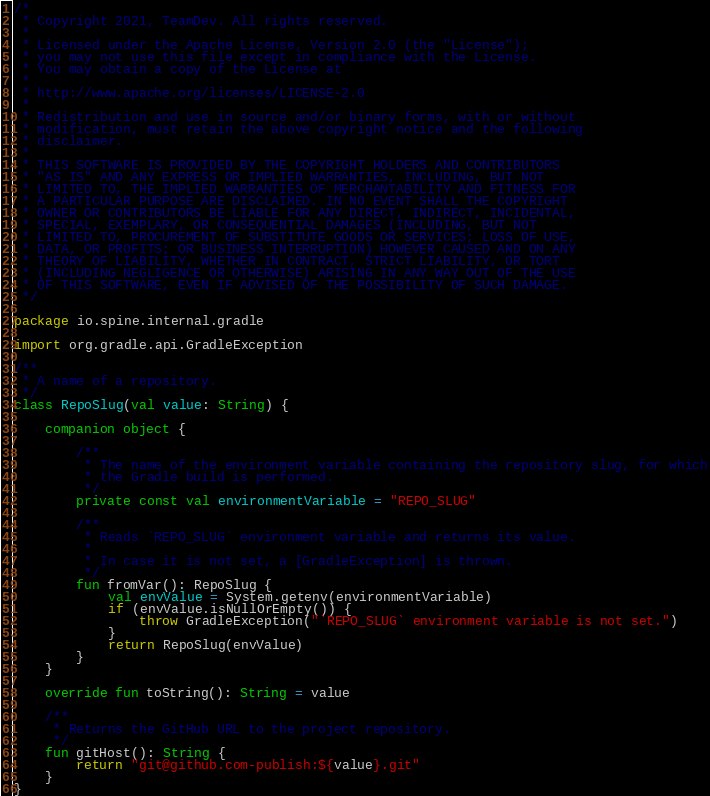<code> <loc_0><loc_0><loc_500><loc_500><_Kotlin_>/*
 * Copyright 2021, TeamDev. All rights reserved.
 *
 * Licensed under the Apache License, Version 2.0 (the "License");
 * you may not use this file except in compliance with the License.
 * You may obtain a copy of the License at
 *
 * http://www.apache.org/licenses/LICENSE-2.0
 *
 * Redistribution and use in source and/or binary forms, with or without
 * modification, must retain the above copyright notice and the following
 * disclaimer.
 *
 * THIS SOFTWARE IS PROVIDED BY THE COPYRIGHT HOLDERS AND CONTRIBUTORS
 * "AS IS" AND ANY EXPRESS OR IMPLIED WARRANTIES, INCLUDING, BUT NOT
 * LIMITED TO, THE IMPLIED WARRANTIES OF MERCHANTABILITY AND FITNESS FOR
 * A PARTICULAR PURPOSE ARE DISCLAIMED. IN NO EVENT SHALL THE COPYRIGHT
 * OWNER OR CONTRIBUTORS BE LIABLE FOR ANY DIRECT, INDIRECT, INCIDENTAL,
 * SPECIAL, EXEMPLARY, OR CONSEQUENTIAL DAMAGES (INCLUDING, BUT NOT
 * LIMITED TO, PROCUREMENT OF SUBSTITUTE GOODS OR SERVICES; LOSS OF USE,
 * DATA, OR PROFITS; OR BUSINESS INTERRUPTION) HOWEVER CAUSED AND ON ANY
 * THEORY OF LIABILITY, WHETHER IN CONTRACT, STRICT LIABILITY, OR TORT
 * (INCLUDING NEGLIGENCE OR OTHERWISE) ARISING IN ANY WAY OUT OF THE USE
 * OF THIS SOFTWARE, EVEN IF ADVISED OF THE POSSIBILITY OF SUCH DAMAGE.
 */

package io.spine.internal.gradle

import org.gradle.api.GradleException

/**
 * A name of a repository.
 */
class RepoSlug(val value: String) {

    companion object {

        /**
         * The name of the environment variable containing the repository slug, for which
         * the Gradle build is performed.
         */
        private const val environmentVariable = "REPO_SLUG"

        /**
         * Reads `REPO_SLUG` environment variable and returns its value.
         *
         * In case it is not set, a [GradleException] is thrown.
         */
        fun fromVar(): RepoSlug {
            val envValue = System.getenv(environmentVariable)
            if (envValue.isNullOrEmpty()) {
                throw GradleException("`REPO_SLUG` environment variable is not set.")
            }
            return RepoSlug(envValue)
        }
    }

    override fun toString(): String = value

    /**
     * Returns the GitHub URL to the project repository.
     */
    fun gitHost(): String {
        return "git@github.com-publish:${value}.git"
    }
}
</code> 